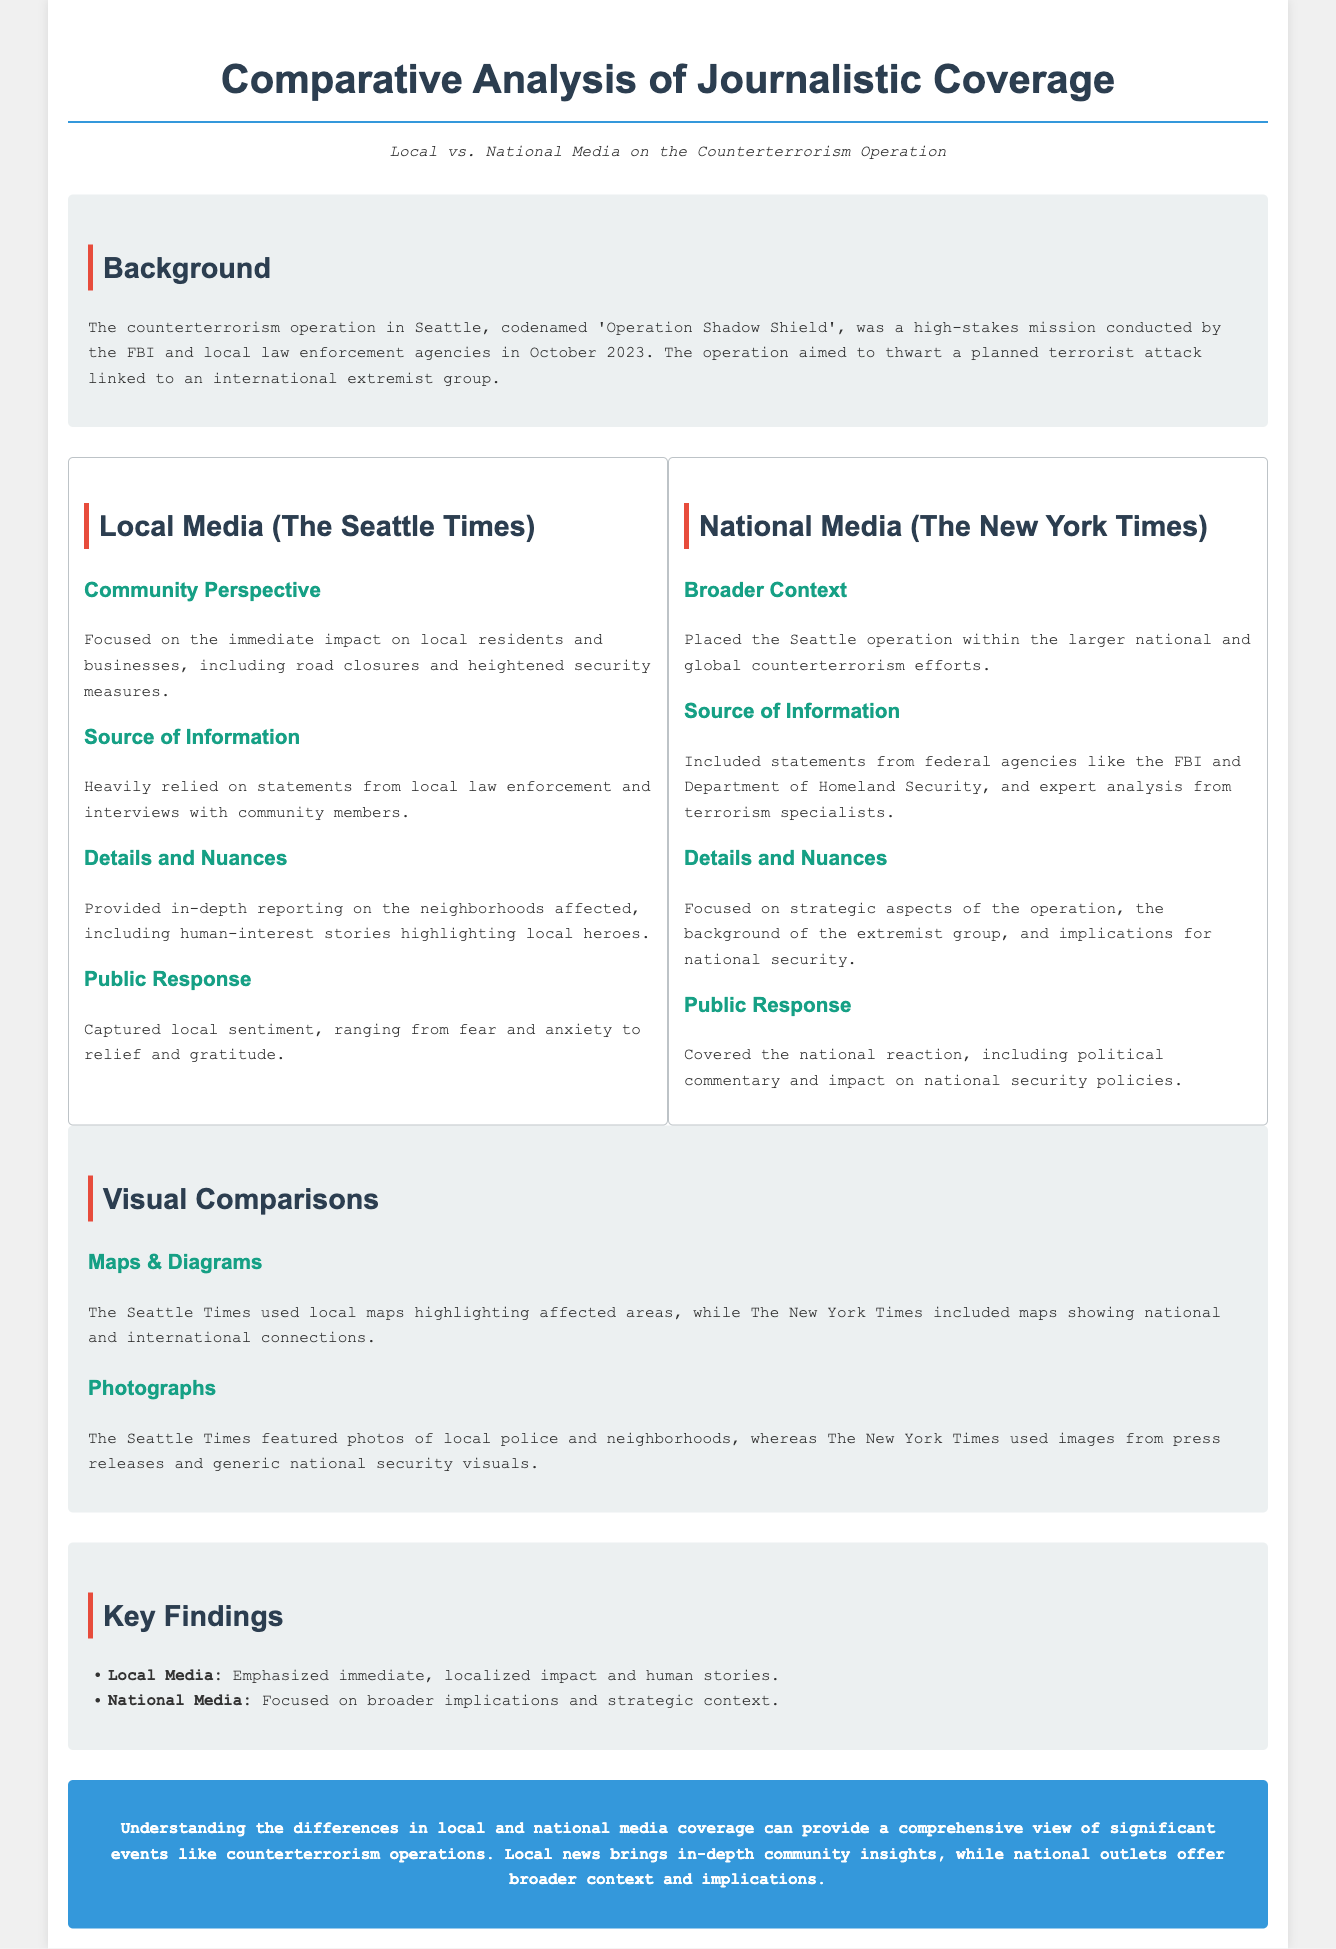What was the operation's codename? The operation conducted by the FBI and local law enforcement is referred to as 'Operation Shadow Shield'.
Answer: Operation Shadow Shield Which media outlet focused on local impacts? The Seattle Times emphasized the immediate community effects in its coverage.
Answer: The Seattle Times What type of sources did local media rely on? Local media heavily relied on statements from local law enforcement and interviews with community members.
Answer: Local law enforcement and community members What was a major theme in the national media's coverage? The New York Times focused on placing the operation within the broader context of national and global counterterrorism efforts.
Answer: Broader context What did the Seattle Times use to highlight affected areas? The Seattle Times included local maps marking specific neighborhoods impacted by the operation.
Answer: Local maps How did public sentiment vary according to local media? The local media captured a range of local sentiments, including fear, anxiety, relief, and gratitude.
Answer: Fear and anxiety to relief and gratitude What kind of photographs did the local media feature? The Seattle Times showcased photos of local police and neighborhoods relevant to the operation.
Answer: Local police and neighborhoods What did the national media primarily focus on in terms of consequences? The national media covered the implications for national security policies following the operation.
Answer: National security policies 